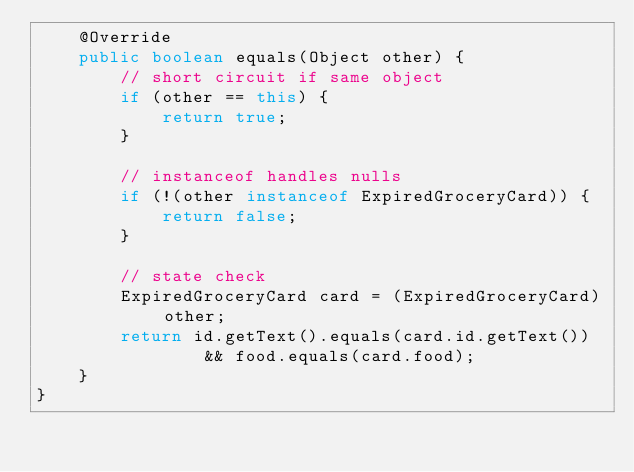Convert code to text. <code><loc_0><loc_0><loc_500><loc_500><_Java_>    @Override
    public boolean equals(Object other) {
        // short circuit if same object
        if (other == this) {
            return true;
        }

        // instanceof handles nulls
        if (!(other instanceof ExpiredGroceryCard)) {
            return false;
        }

        // state check
        ExpiredGroceryCard card = (ExpiredGroceryCard) other;
        return id.getText().equals(card.id.getText())
                && food.equals(card.food);
    }
}
</code> 